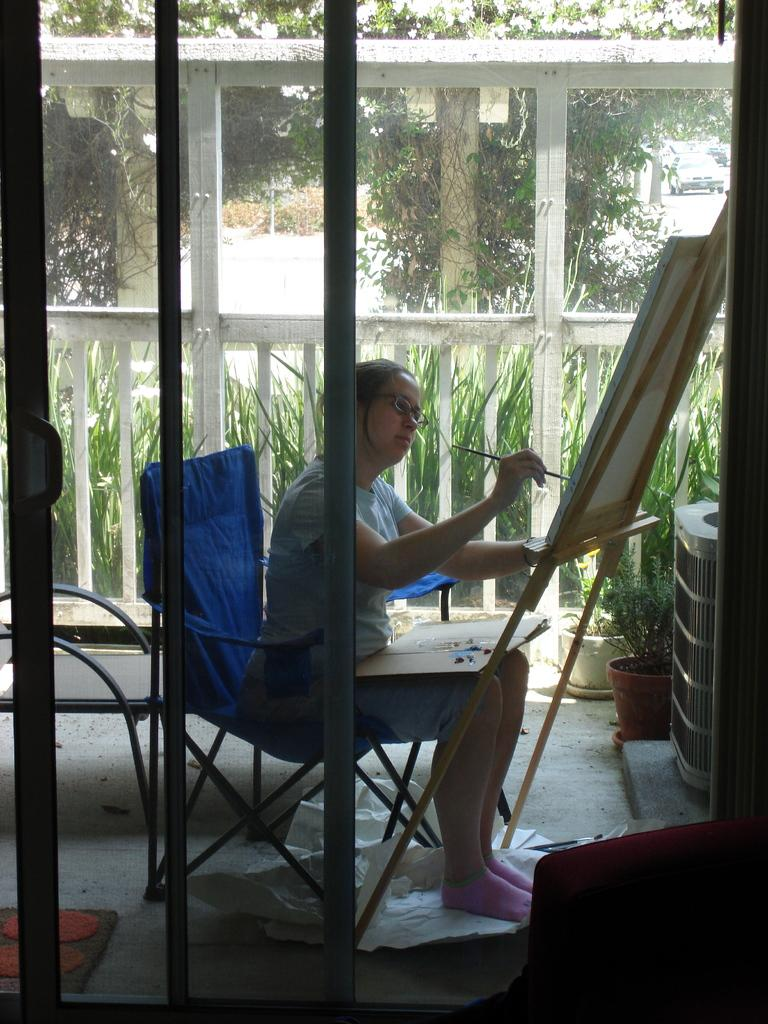What type of door can be seen in the image? There is a glass door in the image. What is the lady in the image doing? The lady is sitting on a chair and painting on a chart. What can be seen in the background of the image? There is a fence, grass, and trees visible in the image. What mode of transportation is present in the image? There is a vehicle present in the image. What type of signage is visible in the image? There is a sign board in the image. What type of pan is the lady using to paint on the chart in the image? There is no pan present in the image; the lady is using a paintbrush to paint on the chart. What flavor of paper is the chart made of in the image? The chart's material is not mentioned in the image, so it is not possible to determine its flavor. 